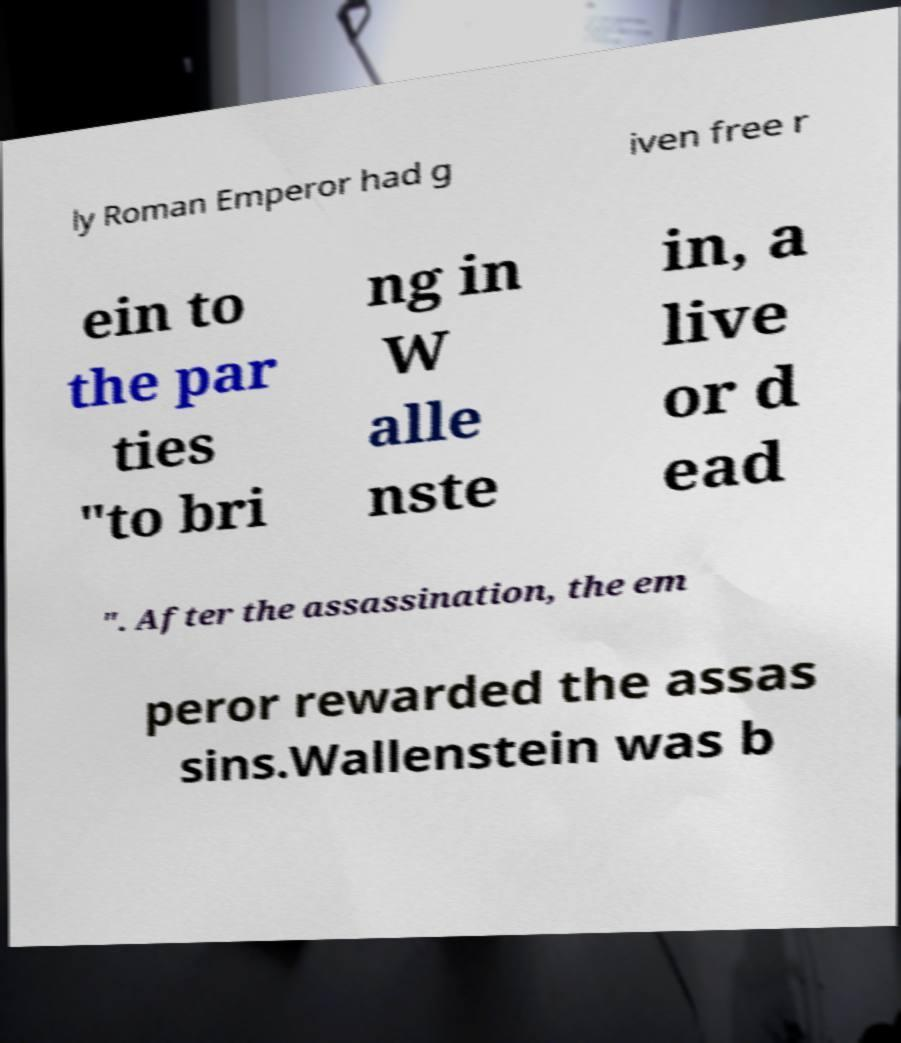Can you read and provide the text displayed in the image?This photo seems to have some interesting text. Can you extract and type it out for me? ly Roman Emperor had g iven free r ein to the par ties "to bri ng in W alle nste in, a live or d ead ". After the assassination, the em peror rewarded the assas sins.Wallenstein was b 